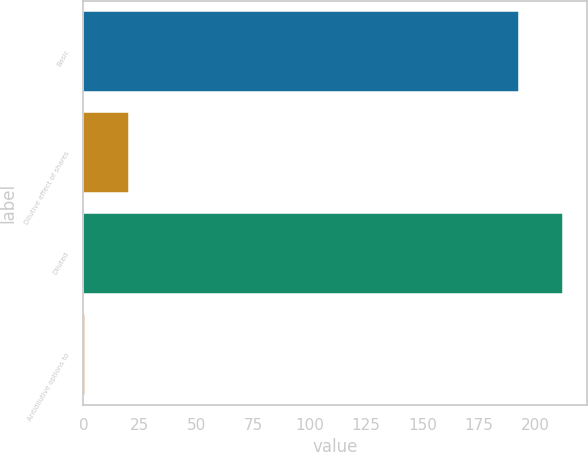Convert chart. <chart><loc_0><loc_0><loc_500><loc_500><bar_chart><fcel>Basic<fcel>Dilutive effect of shares<fcel>Diluted<fcel>Antidilutive options to<nl><fcel>192.7<fcel>20.08<fcel>212.18<fcel>0.6<nl></chart> 